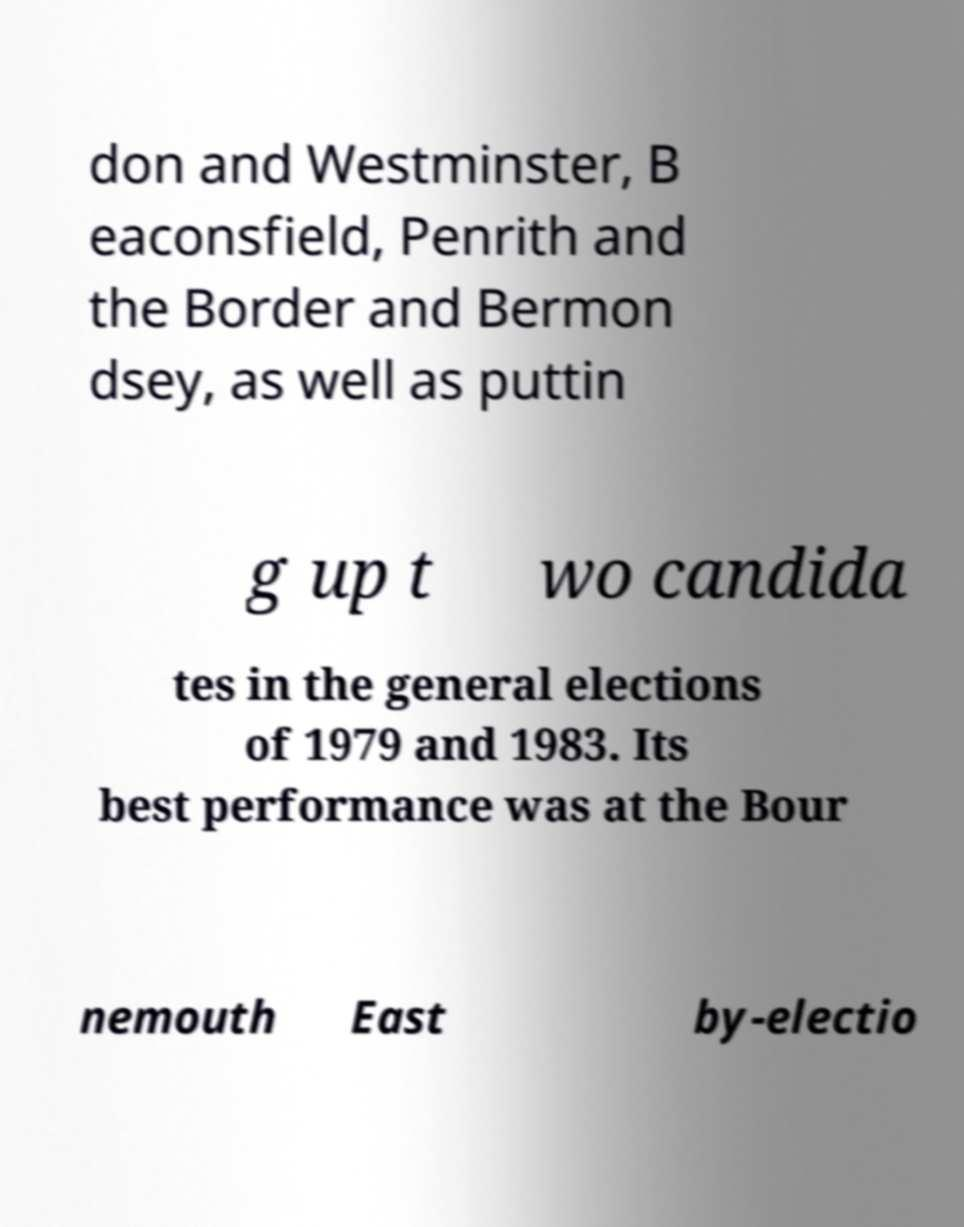There's text embedded in this image that I need extracted. Can you transcribe it verbatim? don and Westminster, B eaconsfield, Penrith and the Border and Bermon dsey, as well as puttin g up t wo candida tes in the general elections of 1979 and 1983. Its best performance was at the Bour nemouth East by-electio 